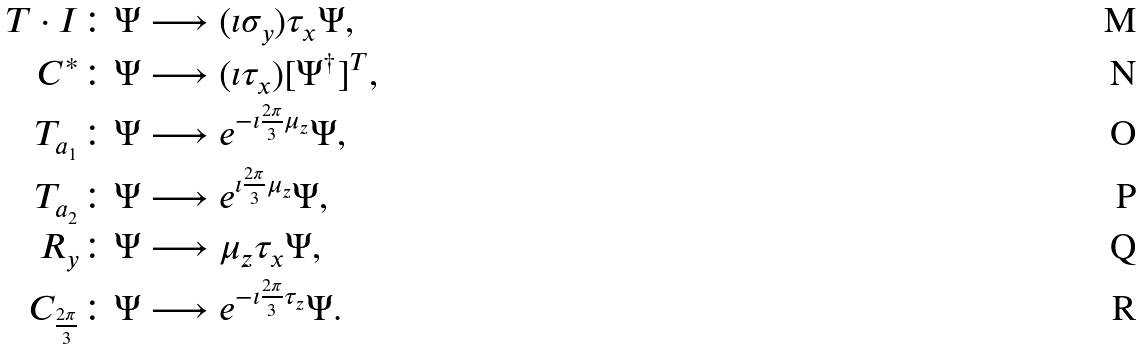<formula> <loc_0><loc_0><loc_500><loc_500>T \cdot I \colon \Psi & \longrightarrow ( \imath \sigma _ { y } ) \tau _ { x } \Psi , \\ C ^ { * } \colon \Psi & \longrightarrow ( \imath \tau _ { x } ) [ \Psi ^ { \dag } ] ^ { T } , \\ T _ { a _ { 1 } } \colon \Psi & \longrightarrow e ^ { - \imath \frac { 2 \pi } { 3 } \mu _ { z } } \Psi , \\ T _ { a _ { 2 } } \colon \Psi & \longrightarrow e ^ { \imath \frac { 2 \pi } { 3 } \mu _ { z } } \Psi , \\ R _ { y } \colon \Psi & \longrightarrow \mu _ { z } \tau _ { x } \Psi , \\ C _ { \frac { 2 \pi } { 3 } } \colon \Psi & \longrightarrow e ^ { - \imath \frac { 2 \pi } { 3 } \tau _ { z } } \Psi .</formula> 